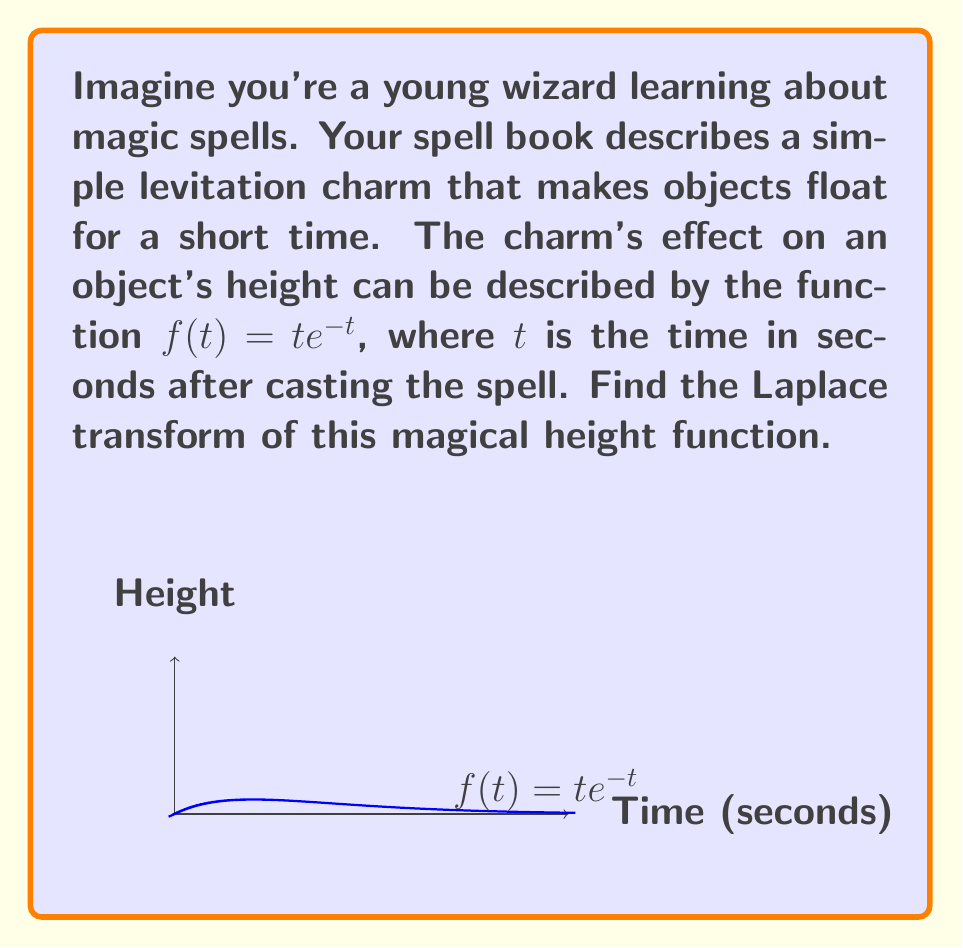What is the answer to this math problem? Let's approach this step-by-step:

1) The Laplace transform of a function $f(t)$ is defined as:

   $$\mathcal{L}\{f(t)\} = F(s) = \int_0^\infty e^{-st}f(t)dt$$

2) In our case, $f(t) = te^{-t}$, so we need to calculate:

   $$\mathcal{L}\{te^{-t}\} = \int_0^\infty e^{-st}te^{-t}dt$$

3) Simplify the integrand:

   $$\int_0^\infty te^{-(s+1)t}dt$$

4) This integral can be solved using integration by parts. Let $u = t$ and $dv = e^{-(s+1)t}dt$. Then $du = dt$ and $v = -\frac{1}{s+1}e^{-(s+1)t}$.

5) Applying integration by parts:

   $$\left[-\frac{t}{s+1}e^{-(s+1)t}\right]_0^\infty + \int_0^\infty \frac{1}{s+1}e^{-(s+1)t}dt$$

6) The first term evaluates to zero at both limits. For the second term:

   $$\frac{1}{s+1}\int_0^\infty e^{-(s+1)t}dt = \frac{1}{s+1}\left[-\frac{1}{s+1}e^{-(s+1)t}\right]_0^\infty$$

7) Evaluating the limits:

   $$\frac{1}{s+1}\left(0 - \left(-\frac{1}{s+1}\right)\right) = \frac{1}{(s+1)^2}$$

Therefore, the Laplace transform of our magical height function is $\frac{1}{(s+1)^2}$.
Answer: $$\mathcal{L}\{te^{-t}\} = \frac{1}{(s+1)^2}$$ 